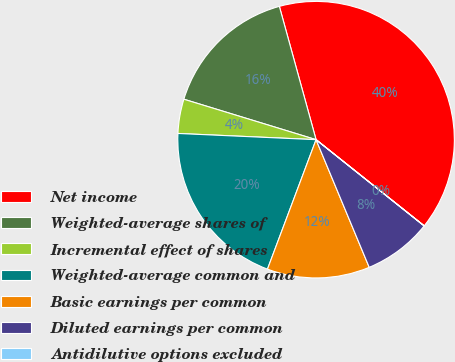Convert chart to OTSL. <chart><loc_0><loc_0><loc_500><loc_500><pie_chart><fcel>Net income<fcel>Weighted-average shares of<fcel>Incremental effect of shares<fcel>Weighted-average common and<fcel>Basic earnings per common<fcel>Diluted earnings per common<fcel>Antidilutive options excluded<nl><fcel>39.99%<fcel>16.0%<fcel>4.01%<fcel>20.0%<fcel>12.0%<fcel>8.0%<fcel>0.01%<nl></chart> 